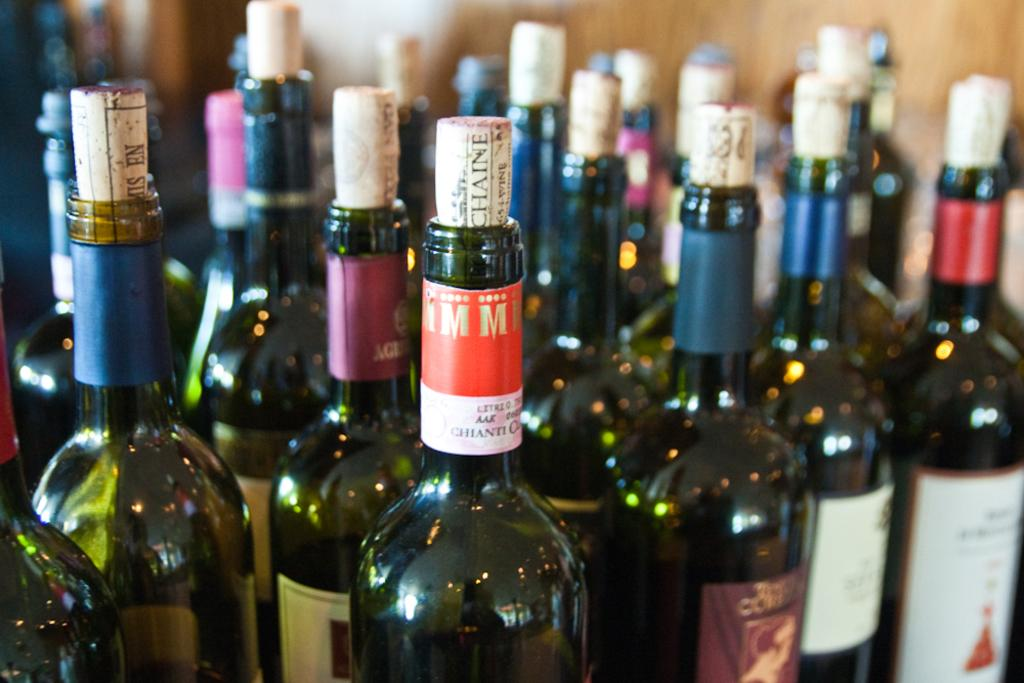Provide a one-sentence caption for the provided image. Several corked bottles of alcohol including a Chainti. 